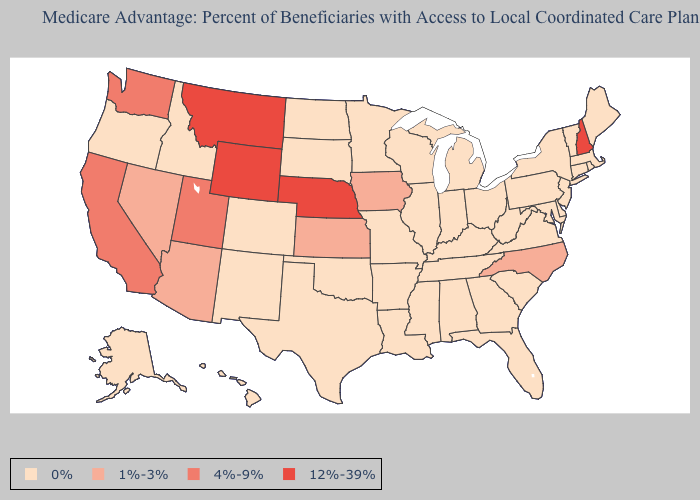Which states hav the highest value in the Northeast?
Answer briefly. New Hampshire. Which states have the highest value in the USA?
Quick response, please. Montana, Nebraska, New Hampshire, Wyoming. What is the value of Ohio?
Concise answer only. 0%. Name the states that have a value in the range 12%-39%?
Concise answer only. Montana, Nebraska, New Hampshire, Wyoming. Name the states that have a value in the range 12%-39%?
Quick response, please. Montana, Nebraska, New Hampshire, Wyoming. Does New Hampshire have the lowest value in the USA?
Give a very brief answer. No. What is the value of Georgia?
Short answer required. 0%. What is the highest value in the USA?
Concise answer only. 12%-39%. Name the states that have a value in the range 4%-9%?
Short answer required. California, Utah, Washington. What is the value of Oklahoma?
Keep it brief. 0%. Does the first symbol in the legend represent the smallest category?
Write a very short answer. Yes. What is the highest value in the USA?
Be succinct. 12%-39%. What is the lowest value in the USA?
Short answer required. 0%. Is the legend a continuous bar?
Give a very brief answer. No. What is the value of Missouri?
Concise answer only. 0%. 